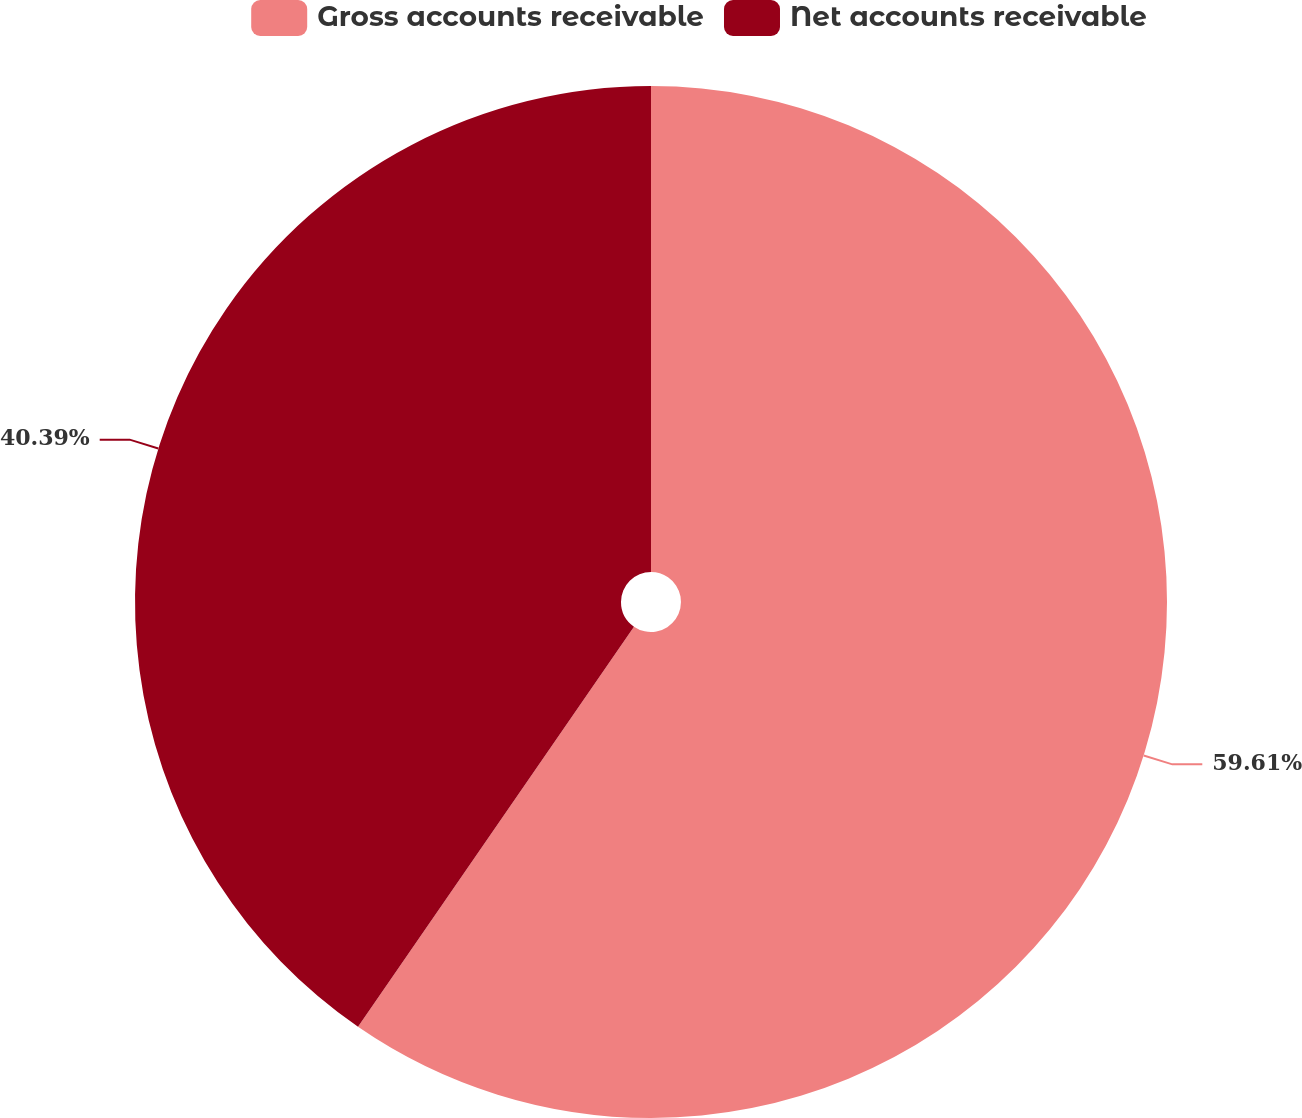Convert chart to OTSL. <chart><loc_0><loc_0><loc_500><loc_500><pie_chart><fcel>Gross accounts receivable<fcel>Net accounts receivable<nl><fcel>59.61%<fcel>40.39%<nl></chart> 